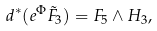Convert formula to latex. <formula><loc_0><loc_0><loc_500><loc_500>d ^ { * } ( e ^ { \Phi } \tilde { F } _ { 3 } ) = { F } _ { 5 } \wedge { H } _ { 3 } ,</formula> 